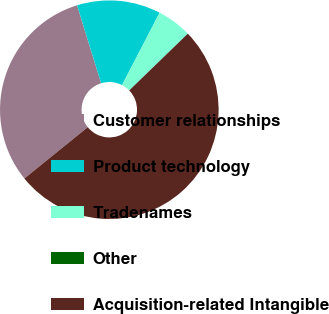Convert chart to OTSL. <chart><loc_0><loc_0><loc_500><loc_500><pie_chart><fcel>Customer relationships<fcel>Product technology<fcel>Tradenames<fcel>Other<fcel>Acquisition-related Intangible<nl><fcel>31.07%<fcel>12.38%<fcel>5.14%<fcel>0.0%<fcel>51.41%<nl></chart> 